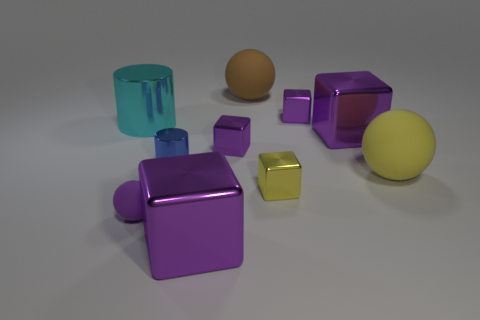Subtract all big brown rubber balls. How many balls are left? 2 Subtract all yellow cubes. How many cubes are left? 4 Subtract all spheres. How many objects are left? 7 Subtract 2 cubes. How many cubes are left? 3 Subtract all blue cylinders. Subtract all yellow blocks. How many cylinders are left? 1 Subtract all yellow blocks. How many blue cylinders are left? 1 Subtract all tiny yellow shiny things. Subtract all yellow rubber spheres. How many objects are left? 8 Add 5 tiny purple metal objects. How many tiny purple metal objects are left? 7 Add 6 blue shiny blocks. How many blue shiny blocks exist? 6 Subtract 0 gray cylinders. How many objects are left? 10 